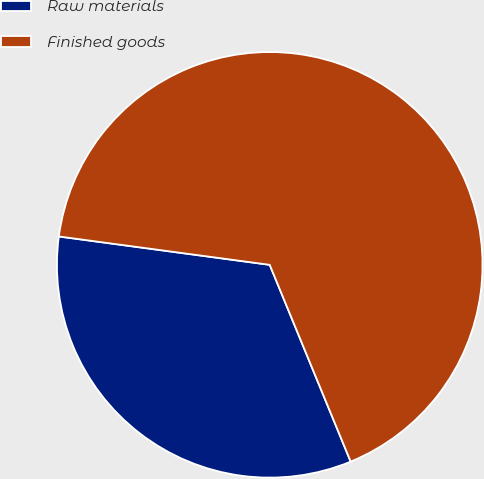Convert chart to OTSL. <chart><loc_0><loc_0><loc_500><loc_500><pie_chart><fcel>Raw materials<fcel>Finished goods<nl><fcel>33.34%<fcel>66.66%<nl></chart> 